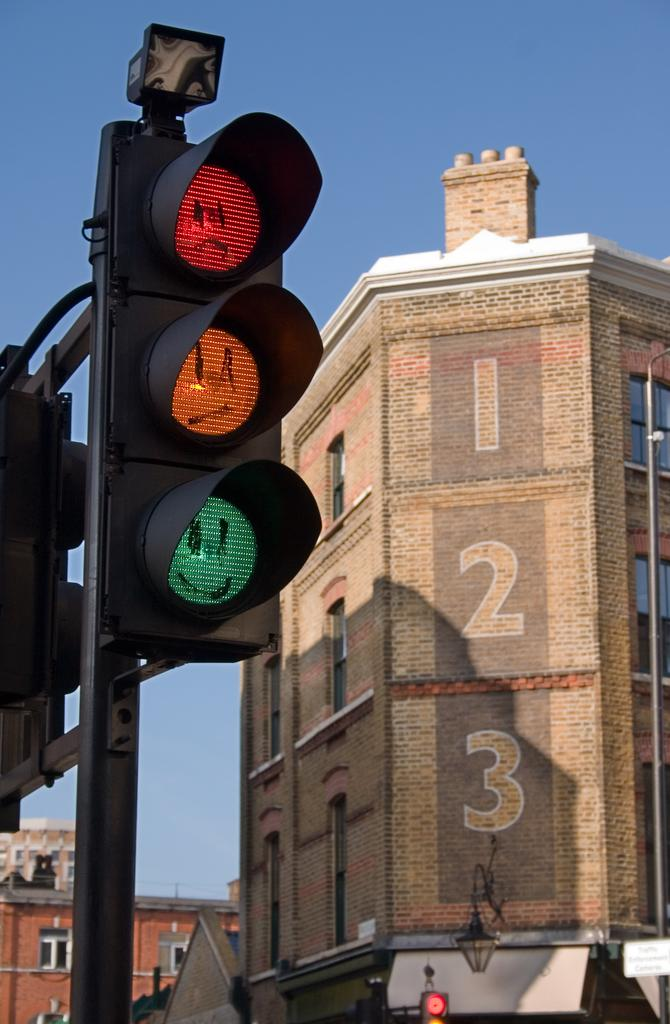<image>
Share a concise interpretation of the image provided. A three story brick building with the numbers "1, 2, and 3" on the corner. 